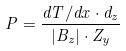Convert formula to latex. <formula><loc_0><loc_0><loc_500><loc_500>P = \frac { d T / d x \cdot d _ { z } } { | B _ { z } | \cdot Z _ { y } }</formula> 